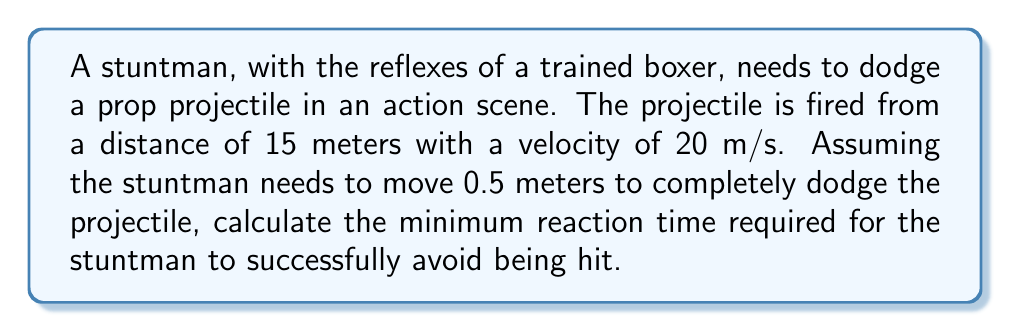Solve this math problem. To solve this problem, we need to follow these steps:

1. Calculate the time it takes for the projectile to reach the stuntman:
   Let's call this time $t_p$ (time of projectile).
   
   Using the formula: $distance = velocity \times time$
   
   $$15 = 20 \times t_p$$
   $$t_p = \frac{15}{20} = 0.75 \text{ seconds}$$

2. Calculate the time it takes for the stuntman to move 0.5 meters:
   We need to use the equation of motion for constant acceleration:
   $$s = \frac{1}{2}at^2$$
   
   Where $s$ is displacement (0.5 m), $a$ is acceleration, and $t$ is time.
   
   The average human acceleration from a standing start is approximately 5 m/s².
   
   $$0.5 = \frac{1}{2} \times 5 \times t^2$$
   $$t^2 = \frac{0.5 \times 2}{5} = 0.2$$
   $$t = \sqrt{0.2} \approx 0.447 \text{ seconds}$$

3. The minimum reaction time is the difference between the time the projectile takes to reach the stuntman and the time it takes for the stuntman to move:

   $$t_{reaction} = t_p - t = 0.75 - 0.447 = 0.303 \text{ seconds}$$

Therefore, the stuntman needs a minimum reaction time of approximately 0.303 seconds to successfully dodge the projectile.
Answer: 0.303 seconds 